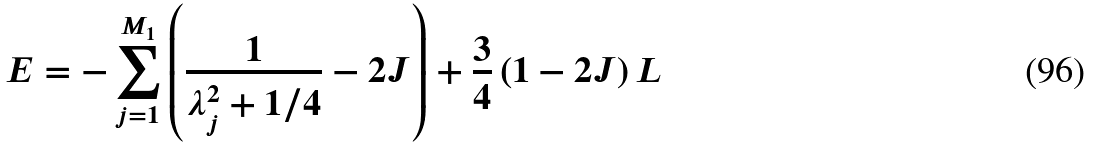Convert formula to latex. <formula><loc_0><loc_0><loc_500><loc_500>E = - \sum _ { j = 1 } ^ { M _ { 1 } } \left ( \frac { 1 } { \lambda _ { j } ^ { 2 } + 1 / 4 } - 2 J \right ) + \frac { 3 } { 4 } \left ( 1 - 2 J \right ) L</formula> 